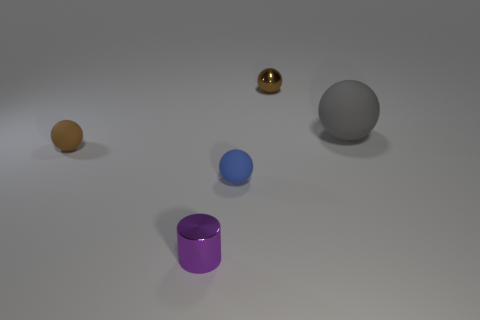If this image was part of an art installation, what themes or ideas might the artist be exploring? This scene might represent themes of minimalism and solitude, emphasizing the beauty of geometric shapes and the use of space. An artist could be exploring the idea of contrast in color and textures, or it could be a study on the play of light and reflections on different surfaces. 